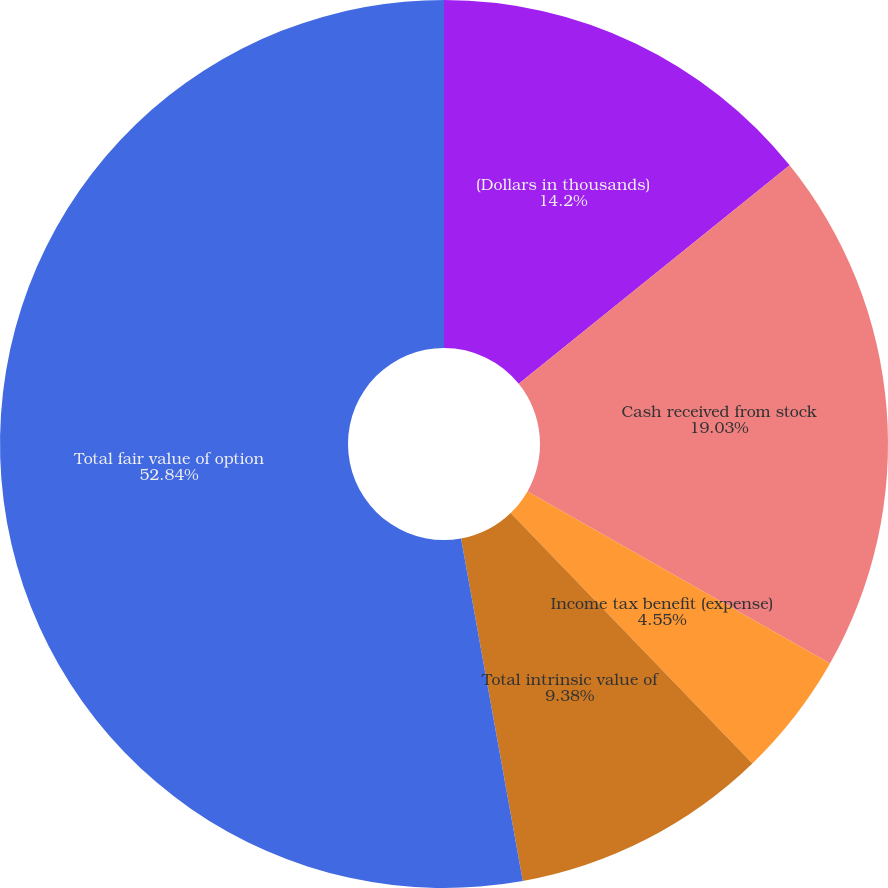Convert chart. <chart><loc_0><loc_0><loc_500><loc_500><pie_chart><fcel>(Dollars in thousands)<fcel>Cash received from stock<fcel>Income tax benefit (expense)<fcel>Total intrinsic value of<fcel>Total fair value of option<nl><fcel>14.2%<fcel>19.03%<fcel>4.55%<fcel>9.38%<fcel>52.84%<nl></chart> 